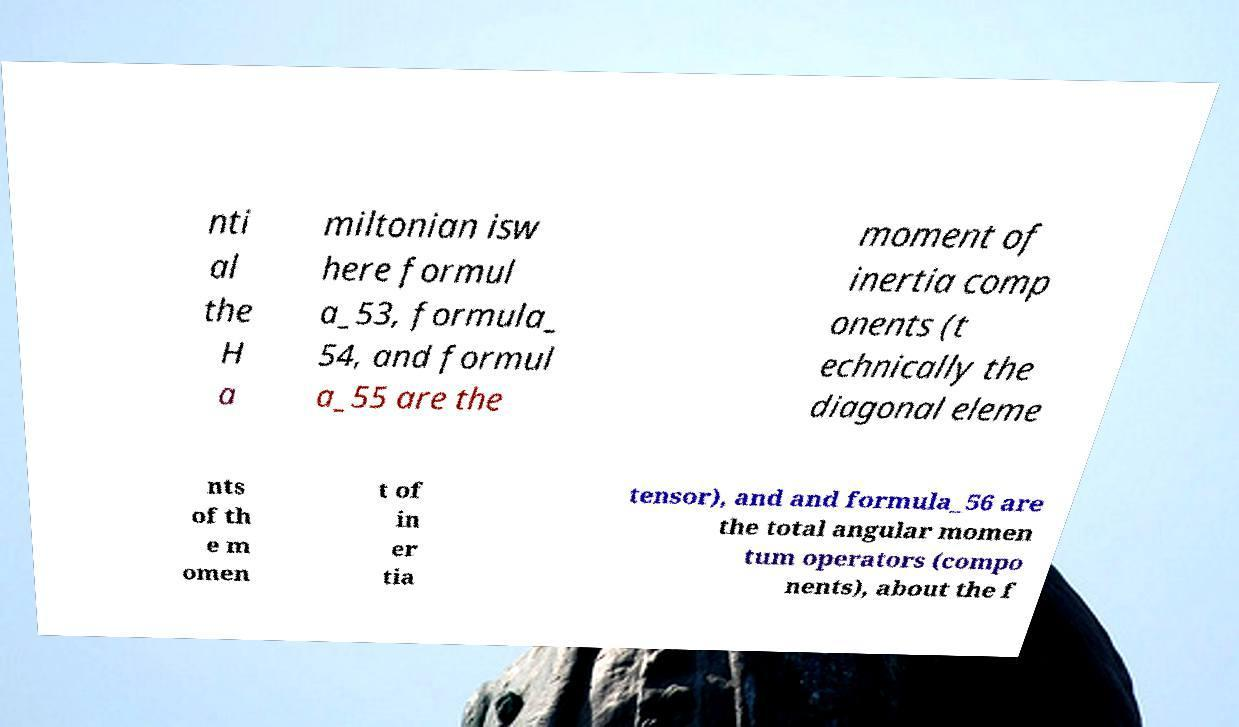Please identify and transcribe the text found in this image. nti al the H a miltonian isw here formul a_53, formula_ 54, and formul a_55 are the moment of inertia comp onents (t echnically the diagonal eleme nts of th e m omen t of in er tia tensor), and and formula_56 are the total angular momen tum operators (compo nents), about the f 